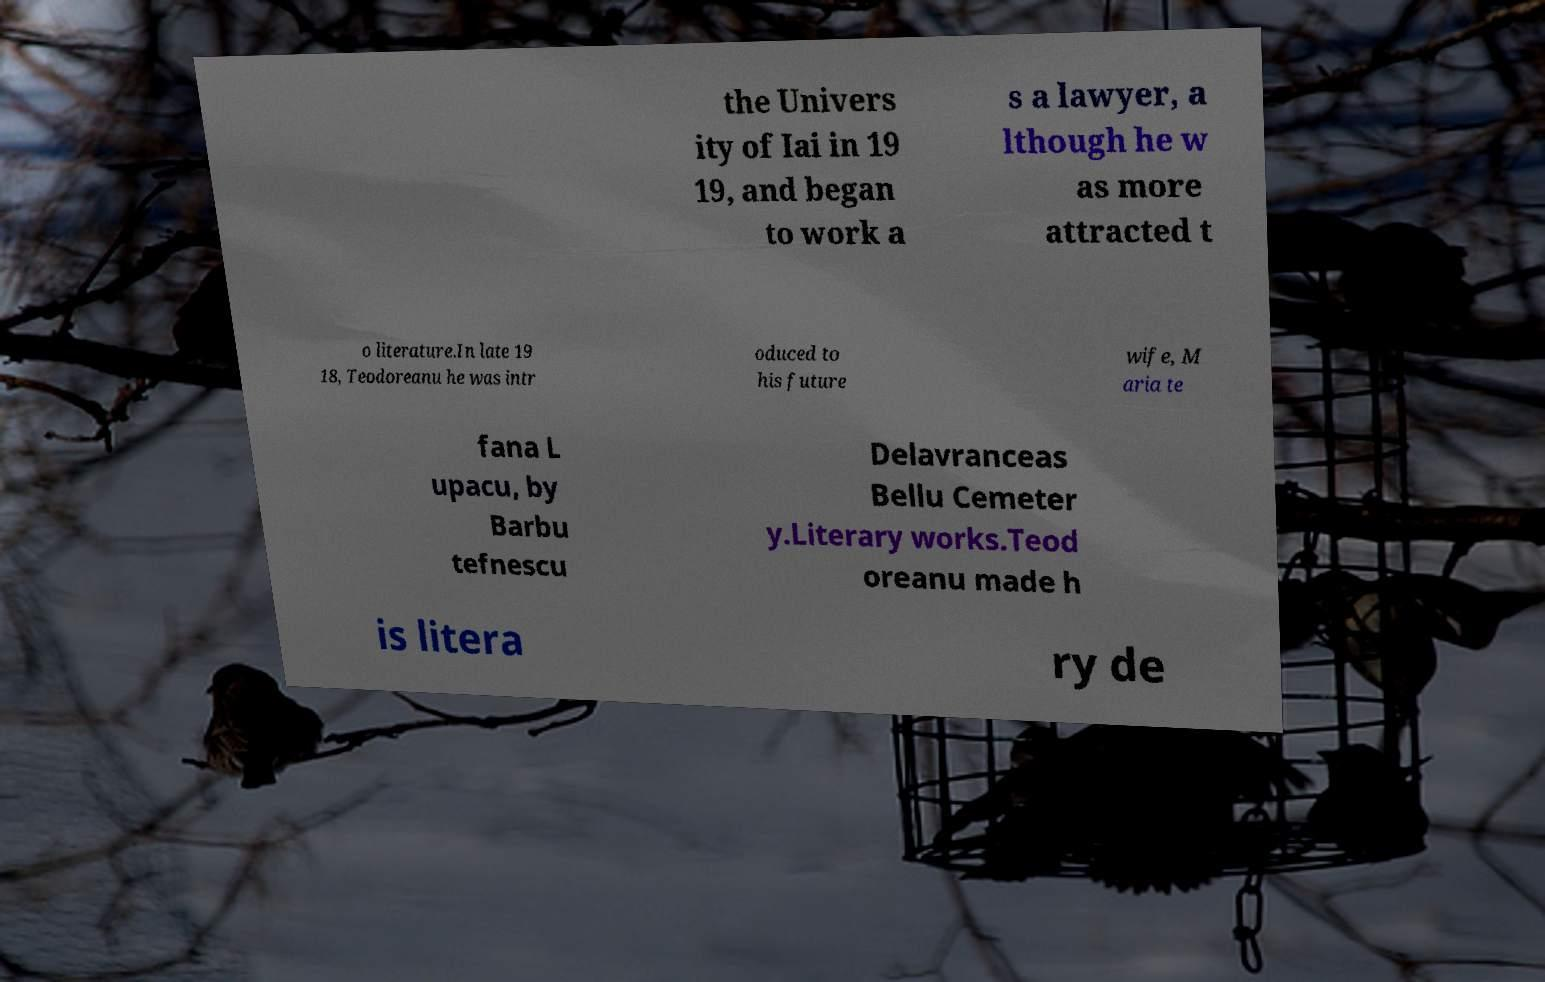Please read and relay the text visible in this image. What does it say? the Univers ity of Iai in 19 19, and began to work a s a lawyer, a lthough he w as more attracted t o literature.In late 19 18, Teodoreanu he was intr oduced to his future wife, M aria te fana L upacu, by Barbu tefnescu Delavranceas Bellu Cemeter y.Literary works.Teod oreanu made h is litera ry de 